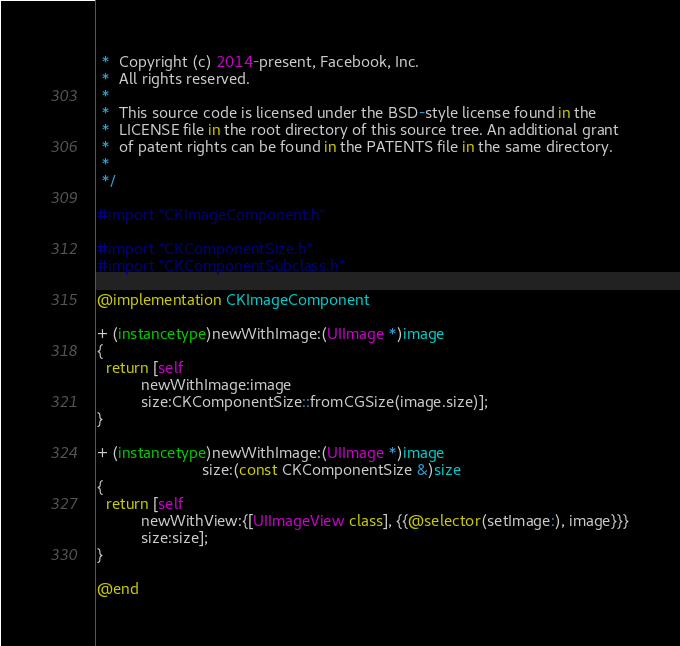Convert code to text. <code><loc_0><loc_0><loc_500><loc_500><_ObjectiveC_> *  Copyright (c) 2014-present, Facebook, Inc.
 *  All rights reserved.
 *
 *  This source code is licensed under the BSD-style license found in the
 *  LICENSE file in the root directory of this source tree. An additional grant 
 *  of patent rights can be found in the PATENTS file in the same directory.
 *
 */

#import "CKImageComponent.h"

#import "CKComponentSize.h"
#import "CKComponentSubclass.h"

@implementation CKImageComponent

+ (instancetype)newWithImage:(UIImage *)image
{
  return [self
          newWithImage:image
          size:CKComponentSize::fromCGSize(image.size)];
}

+ (instancetype)newWithImage:(UIImage *)image
                        size:(const CKComponentSize &)size
{
  return [self
          newWithView:{[UIImageView class], {{@selector(setImage:), image}}}
          size:size];
}

@end
</code> 